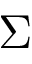<formula> <loc_0><loc_0><loc_500><loc_500>\Sigma</formula> 